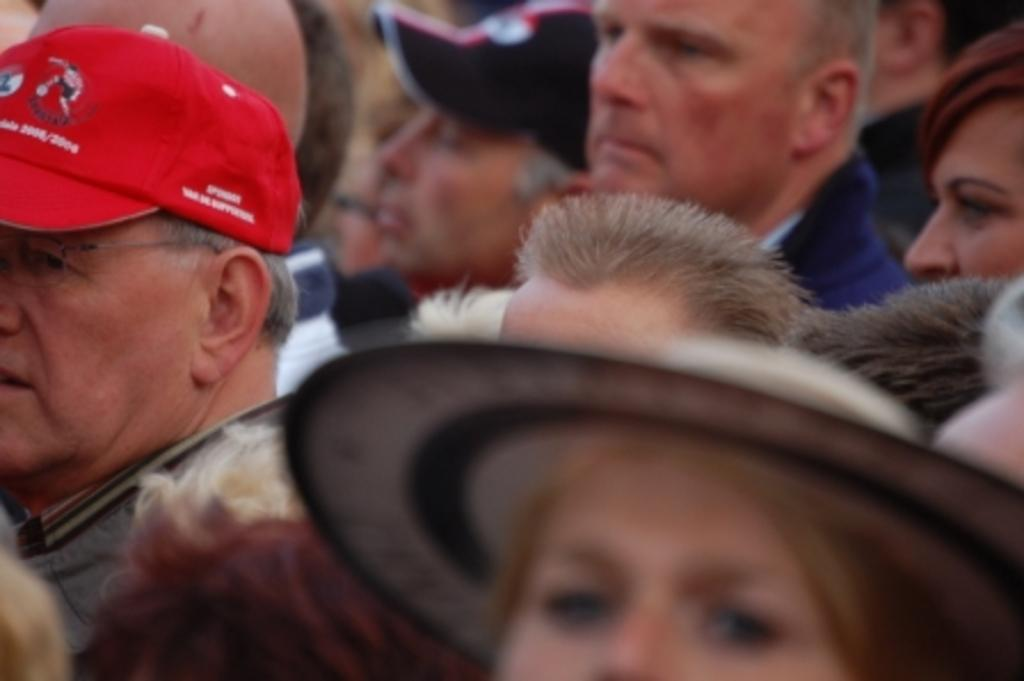How many people are in the image? There is a group of people in the image, but the exact number cannot be determined without more information. Can you describe the group of people in the image? Unfortunately, the provided facts do not give any details about the group of people, so it is impossible to describe them. What type of pollution can be seen in the image? There is no mention of pollution in the provided facts, so it cannot be determined if any pollution is present in the image. 